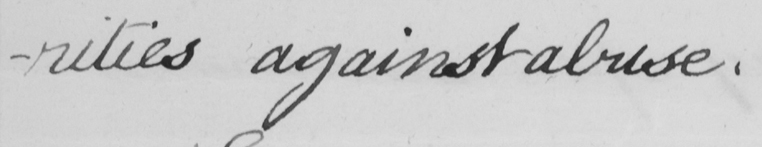What text is written in this handwritten line? -rities against abuse . 